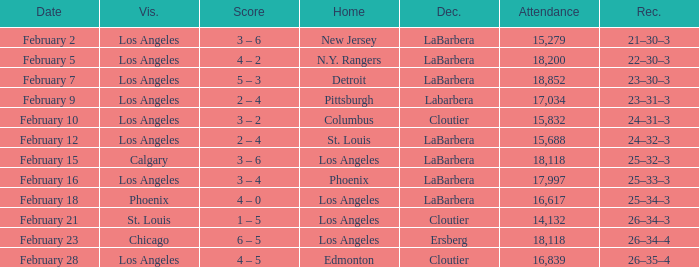What was the decision of the Kings game when Chicago was the visiting team? Ersberg. 